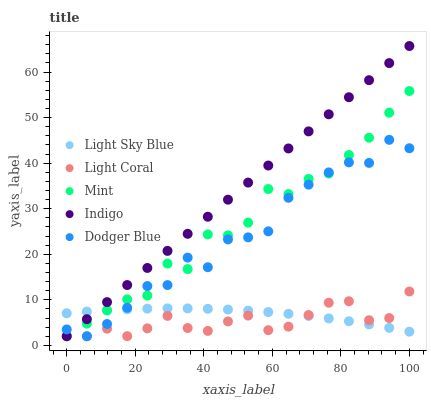Does Light Coral have the minimum area under the curve?
Answer yes or no. Yes. Does Indigo have the maximum area under the curve?
Answer yes or no. Yes. Does Light Sky Blue have the minimum area under the curve?
Answer yes or no. No. Does Light Sky Blue have the maximum area under the curve?
Answer yes or no. No. Is Indigo the smoothest?
Answer yes or no. Yes. Is Dodger Blue the roughest?
Answer yes or no. Yes. Is Light Sky Blue the smoothest?
Answer yes or no. No. Is Light Sky Blue the roughest?
Answer yes or no. No. Does Light Coral have the lowest value?
Answer yes or no. Yes. Does Light Sky Blue have the lowest value?
Answer yes or no. No. Does Indigo have the highest value?
Answer yes or no. Yes. Does Light Sky Blue have the highest value?
Answer yes or no. No. Does Dodger Blue intersect Mint?
Answer yes or no. Yes. Is Dodger Blue less than Mint?
Answer yes or no. No. Is Dodger Blue greater than Mint?
Answer yes or no. No. 